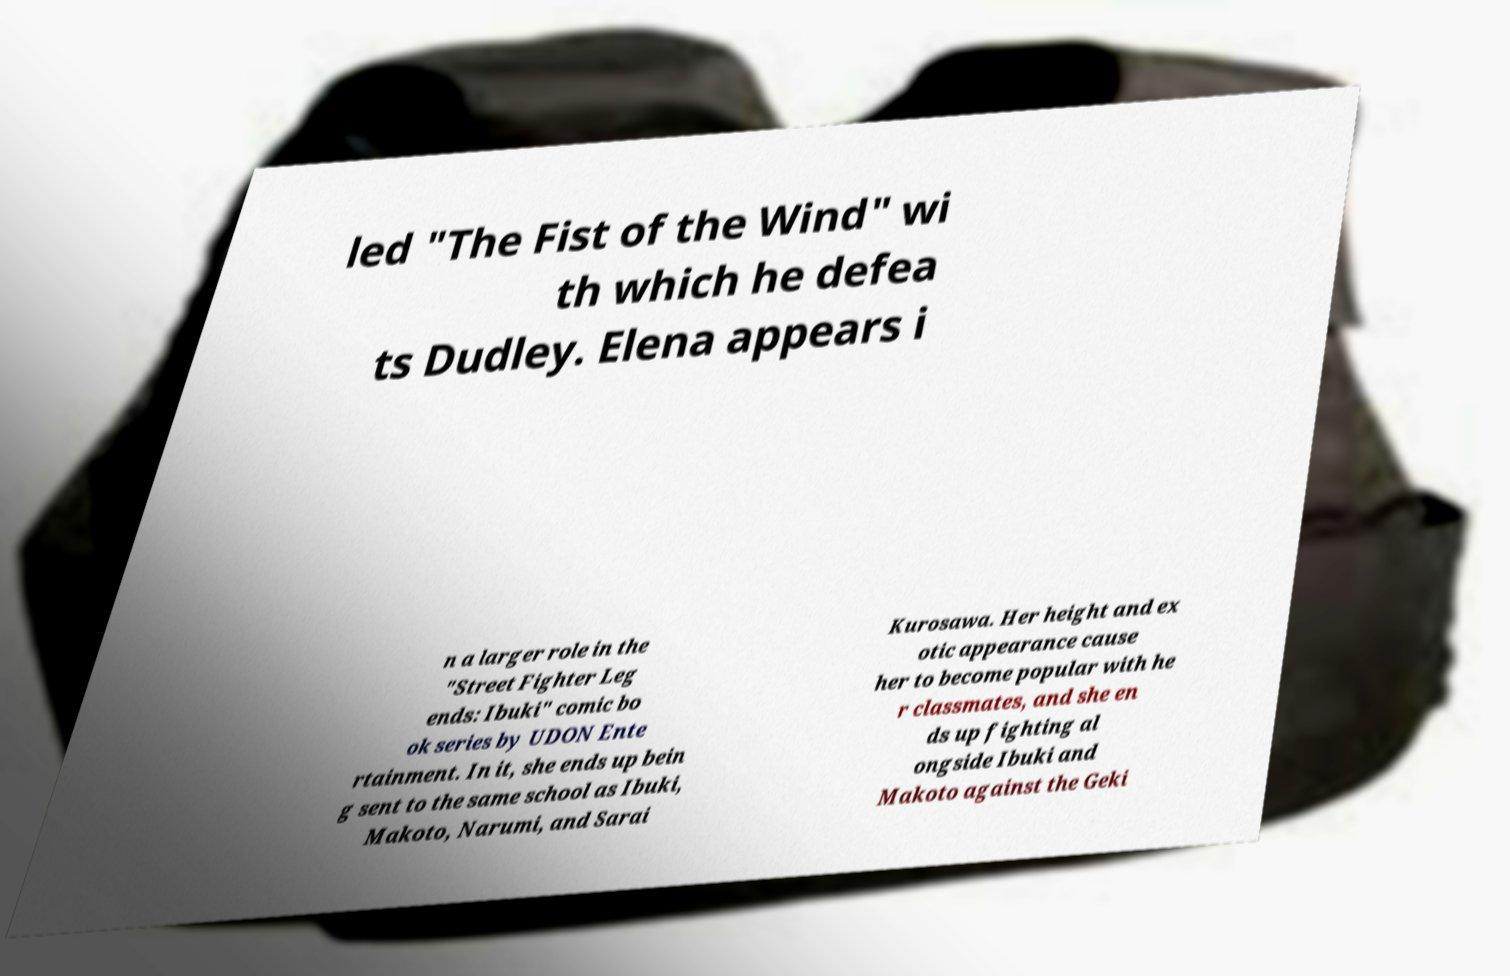Can you accurately transcribe the text from the provided image for me? led "The Fist of the Wind" wi th which he defea ts Dudley. Elena appears i n a larger role in the "Street Fighter Leg ends: Ibuki" comic bo ok series by UDON Ente rtainment. In it, she ends up bein g sent to the same school as Ibuki, Makoto, Narumi, and Sarai Kurosawa. Her height and ex otic appearance cause her to become popular with he r classmates, and she en ds up fighting al ongside Ibuki and Makoto against the Geki 